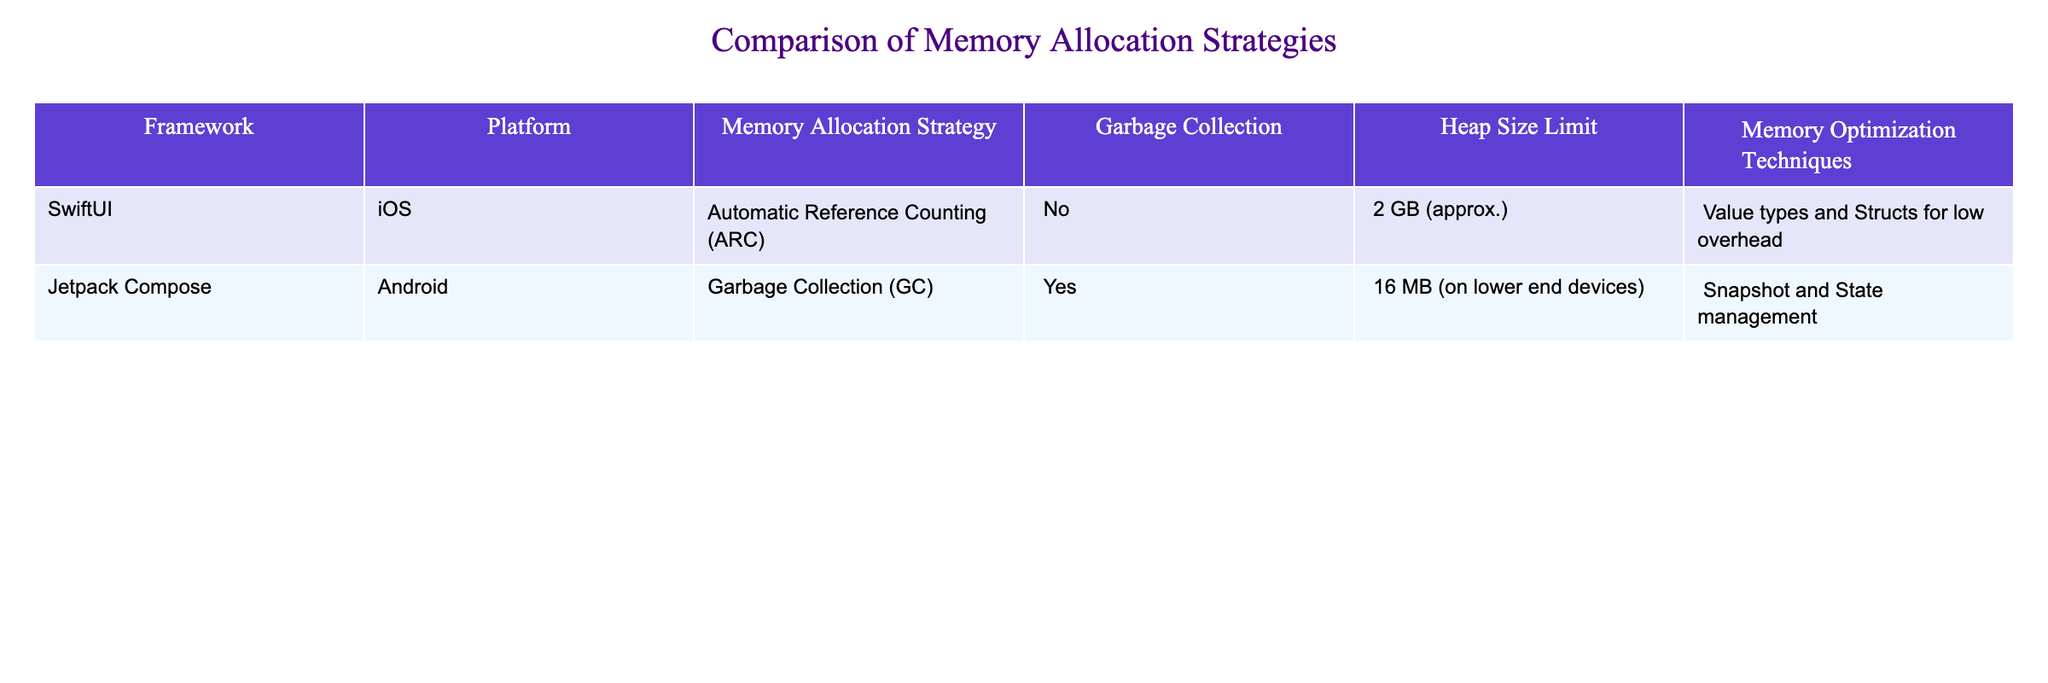What is the memory allocation strategy used in SwiftUI? The table shows that SwiftUI uses Automatic Reference Counting (ARC) as its memory allocation strategy. This is directly retrieved from the second column of the table.
Answer: Automatic Reference Counting (ARC) Does Jetpack Compose utilize garbage collection? According to the table, Jetpack Compose does implement garbage collection (GC), which can be seen in the third column under the "Garbage Collection" header.
Answer: Yes What is the heap size limit for SwiftUI? The heap size limit for SwiftUI is indicated in the table as approximately 2 GB, which is stated in the fifth column under "Heap Size Limit."
Answer: 2 GB Which framework has a greater heap size limit, Jetpack Compose or SwiftUI? The table shows that SwiftUI has a heap size limit of approximately 2 GB, while Jetpack Compose has a limit of 16 MB on lower end devices. Comparing the two, SwiftUI has a greater heap size limit since 2 GB is much larger than 16 MB.
Answer: SwiftUI What memory optimization technique is used in Jetpack Compose? Referring to the last column of the table, it shows that Jetpack Compose utilizes Snapshot and State management as its memory optimization technique.
Answer: Snapshot and State management Is Automatic Reference Counting (ARC) used in any framework for Android? By checking the data in the table, we can see that ARC is not listed under Jetpack Compose, which is the framework for Android in this context. Thus, the answer is no.
Answer: No What is the memory allocation strategy difference between SwiftUI and Jetpack Compose? The memory allocation strategy for SwiftUI is Automatic Reference Counting (ARC), whereas Jetpack Compose uses Garbage Collection (GC). This information is gathered by comparing the third column for both frameworks.
Answer: ARC vs. GC If the heap size limit for Jetpack Compose is 16 MB, how much larger is the heap size limit for SwiftUI? The heap size limit for SwiftUI is approximately 2 GB, which equals 2048 MB. To find out how much larger it is than Jetpack Compose's 16 MB limit, we subtract: 2048 MB - 16 MB = 2032 MB. Thus, SwiftUI's heap size limit is 2032 MB larger than Jetpack Compose's.
Answer: 2032 MB 